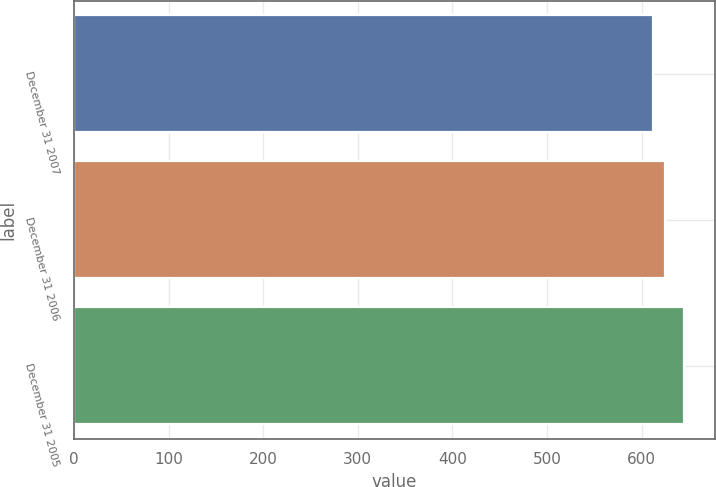Convert chart to OTSL. <chart><loc_0><loc_0><loc_500><loc_500><bar_chart><fcel>December 31 2007<fcel>December 31 2006<fcel>December 31 2005<nl><fcel>611.7<fcel>624.4<fcel>645.2<nl></chart> 